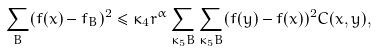<formula> <loc_0><loc_0><loc_500><loc_500>\sum _ { B } ( f ( x ) - f _ { B } ) ^ { 2 } \leq \kappa _ { 4 } r ^ { \alpha } \sum _ { \kappa _ { 5 } B } \sum _ { \kappa _ { 5 } B } ( f ( y ) - f ( x ) ) ^ { 2 } C ( x , y ) ,</formula> 